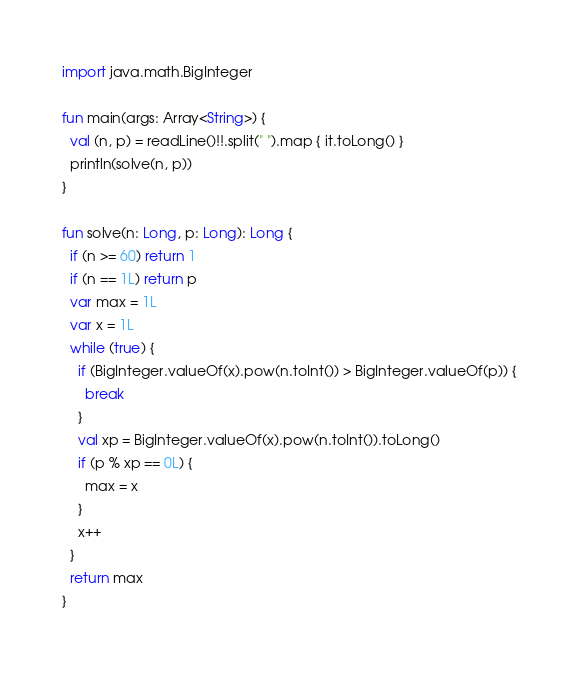<code> <loc_0><loc_0><loc_500><loc_500><_Kotlin_>import java.math.BigInteger

fun main(args: Array<String>) {
  val (n, p) = readLine()!!.split(" ").map { it.toLong() }
  println(solve(n, p))
}

fun solve(n: Long, p: Long): Long {
  if (n >= 60) return 1
  if (n == 1L) return p
  var max = 1L
  var x = 1L
  while (true) {
    if (BigInteger.valueOf(x).pow(n.toInt()) > BigInteger.valueOf(p)) {
      break
    }
    val xp = BigInteger.valueOf(x).pow(n.toInt()).toLong()
    if (p % xp == 0L) {
      max = x
    }
    x++
  }
  return max
}</code> 